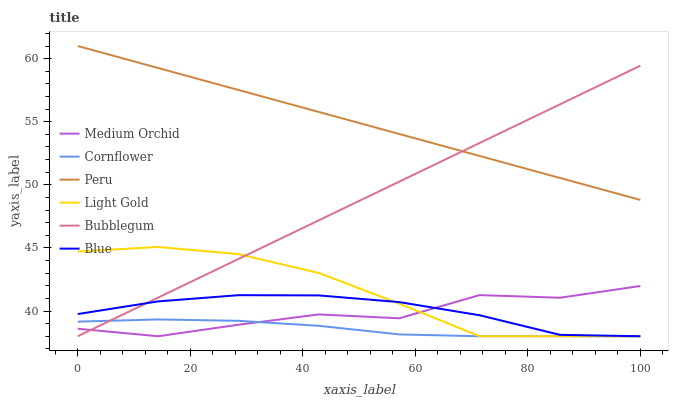Does Cornflower have the minimum area under the curve?
Answer yes or no. Yes. Does Medium Orchid have the minimum area under the curve?
Answer yes or no. No. Does Medium Orchid have the maximum area under the curve?
Answer yes or no. No. Is Medium Orchid the roughest?
Answer yes or no. Yes. Is Cornflower the smoothest?
Answer yes or no. No. Is Cornflower the roughest?
Answer yes or no. No. Does Peru have the lowest value?
Answer yes or no. No. Does Medium Orchid have the highest value?
Answer yes or no. No. Is Cornflower less than Peru?
Answer yes or no. Yes. Is Peru greater than Medium Orchid?
Answer yes or no. Yes. Does Cornflower intersect Peru?
Answer yes or no. No. 